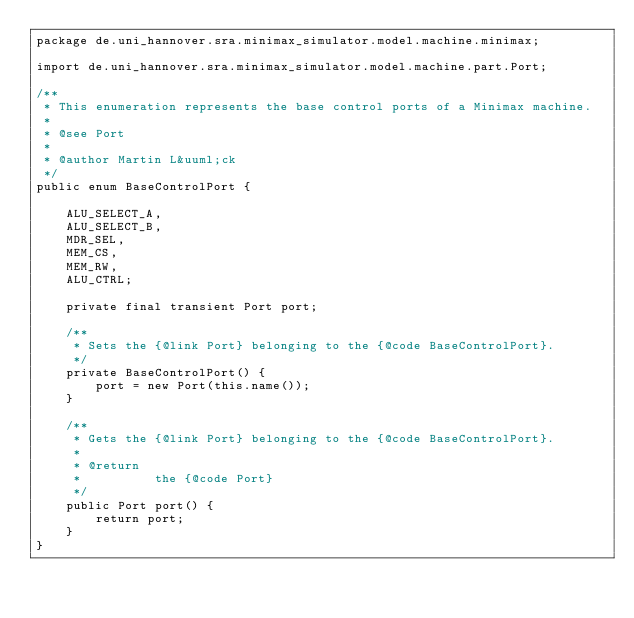Convert code to text. <code><loc_0><loc_0><loc_500><loc_500><_Java_>package de.uni_hannover.sra.minimax_simulator.model.machine.minimax;

import de.uni_hannover.sra.minimax_simulator.model.machine.part.Port;

/**
 * This enumeration represents the base control ports of a Minimax machine.
 *
 * @see Port
 *
 * @author Martin L&uuml;ck
 */
public enum BaseControlPort {

    ALU_SELECT_A,
    ALU_SELECT_B,
    MDR_SEL,
    MEM_CS,
    MEM_RW,
    ALU_CTRL;

    private final transient Port port;

    /**
     * Sets the {@link Port} belonging to the {@code BaseControlPort}.
     */
    private BaseControlPort() {
        port = new Port(this.name());
    }

    /**
     * Gets the {@link Port} belonging to the {@code BaseControlPort}.
     *
     * @return
     *          the {@code Port}
     */
    public Port port() {
        return port;
    }
}</code> 